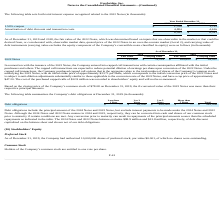According to Everbridge's financial document, What was the cost of the purchased capped calls? The cost of the purchased capped calls of $12.9 million was recorded to shareholders’ equity and will not be re-measured.. The document states: "tes, and have a cap price of approximately $47.20. The cost of the purchased capped calls of $12.9 million was recorded to shareholders’ equity and wi..." Also, can you calculate: What is the average fair value for the period December 31, 2019 to December 31, 2018? To answer this question, I need to perform calculations using the financial data. The calculation is: (215,801+189,802) / 2, which equals 202801.5 (in thousands). This is based on the information: "2022 Notes $ 215,801 $ 79,224 $ 189,802 $ 94,097 2022 Notes $ 215,801 $ 79,224 $ 189,802 $ 94,097..." The key data points involved are: 189,802, 215,801. Also, can you calculate: What is the average Carrying Value for the period December 31, 2019 to December 31, 2018? To answer this question, I need to perform calculations using the financial data. The calculation is: (79,224+94,097) / 2, which equals 86660.5 (in thousands). This is based on the information: "2022 Notes $ 215,801 $ 79,224 $ 189,802 $ 94,097 2022 Notes $ 215,801 $ 79,224 $ 189,802 $ 94,097..." The key data points involved are: 79,224, 94,097. Additionally, In which year was the 2022 Notes fair value less than 200,000 thousands? According to the financial document, 2018. The relevant text states: "2019 2018..." Also, What was the initial strike price? According to the financial document, $33.71 per share. The relevant text states: "tes, with an initial strike price of approximately $33.71 per share, which corresponds to the initial conversion price of the 2022 Notes and is subject to anti-dilutio..." Also, What was the 2022 Notes cap price? According to the financial document, $47.20. The relevant text states: "2022 Notes, and have a cap price of approximately $47.20. The cost of the purchased capped calls of $12.9 million was recorded to shareholders’ equity and w..." 